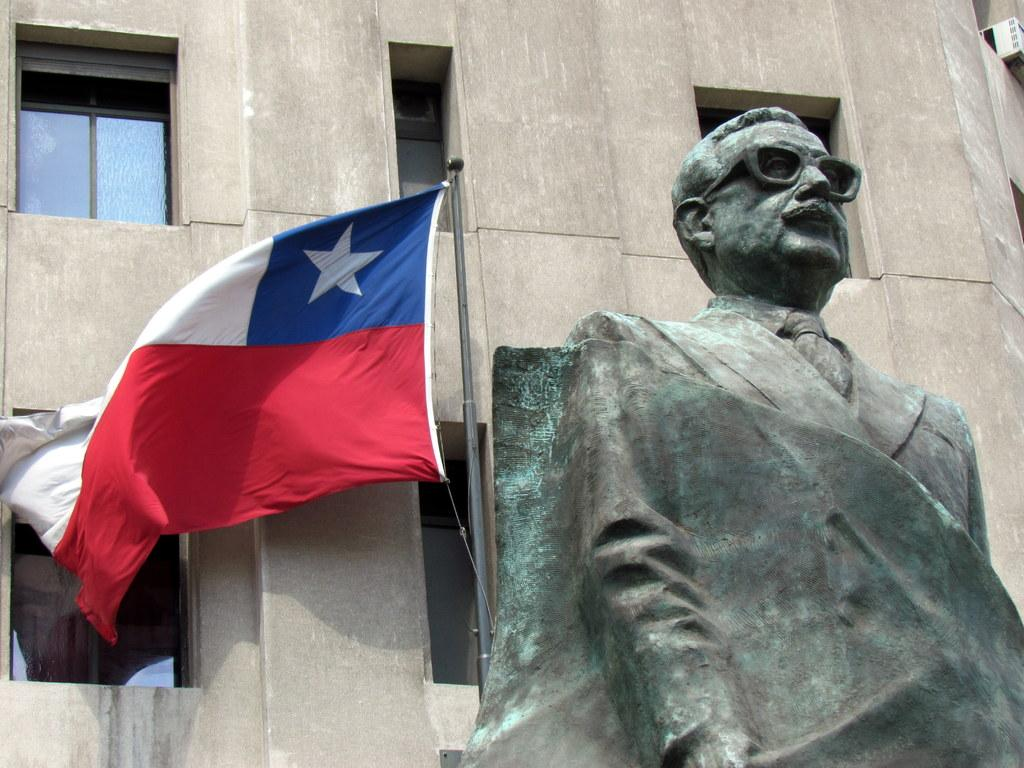What is the main subject in the foreground of the image? There is a statue in the foreground of the image. Where is the flag located in the image? The flag is on the left side of the image. What can be seen in the background of the image? There are many windows visible in the background of the image. What part of the statue is holding a bucket in the image? There is no bucket present in the image, so it cannot be determined which part of the statue might be holding one. 